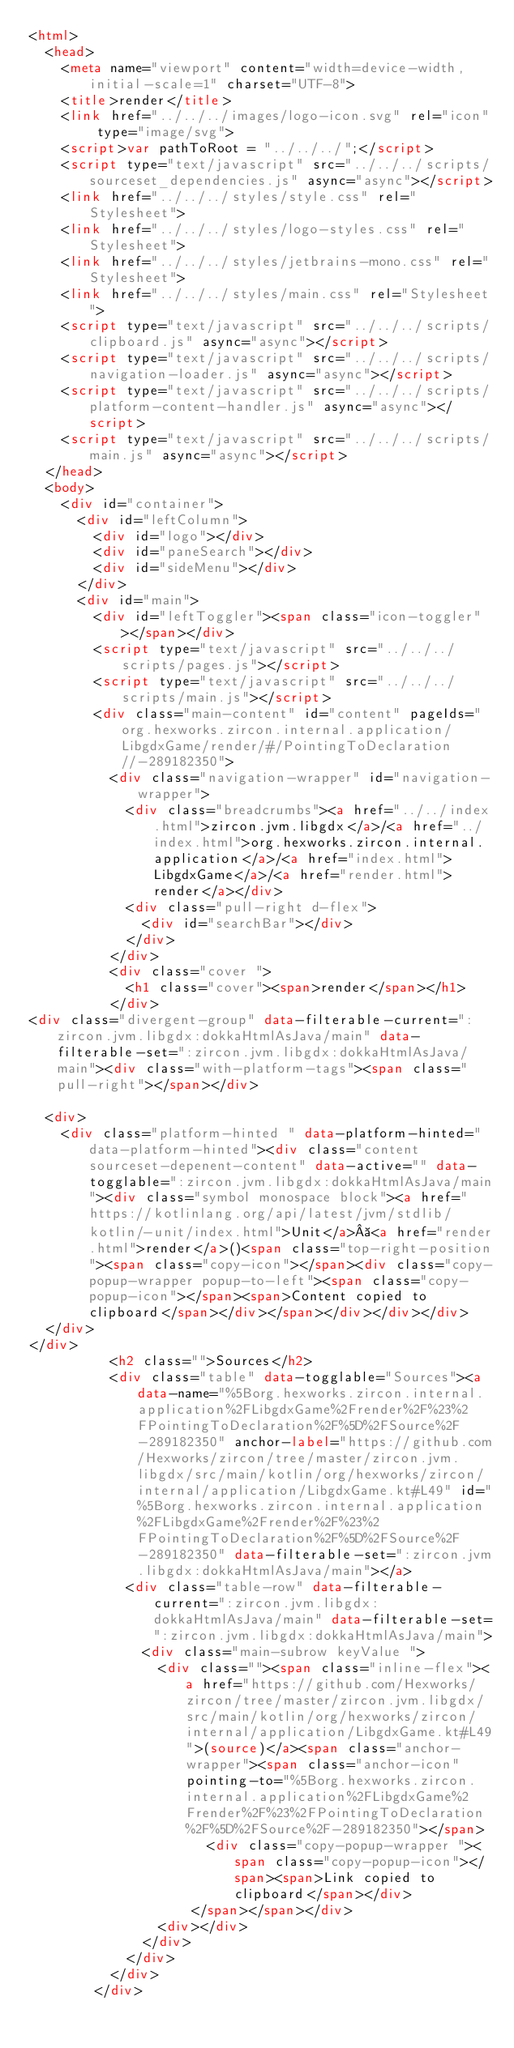Convert code to text. <code><loc_0><loc_0><loc_500><loc_500><_HTML_><html>
  <head>
    <meta name="viewport" content="width=device-width, initial-scale=1" charset="UTF-8">
    <title>render</title>
    <link href="../../../images/logo-icon.svg" rel="icon" type="image/svg">
    <script>var pathToRoot = "../../../";</script>
    <script type="text/javascript" src="../../../scripts/sourceset_dependencies.js" async="async"></script>
    <link href="../../../styles/style.css" rel="Stylesheet">
    <link href="../../../styles/logo-styles.css" rel="Stylesheet">
    <link href="../../../styles/jetbrains-mono.css" rel="Stylesheet">
    <link href="../../../styles/main.css" rel="Stylesheet">
    <script type="text/javascript" src="../../../scripts/clipboard.js" async="async"></script>
    <script type="text/javascript" src="../../../scripts/navigation-loader.js" async="async"></script>
    <script type="text/javascript" src="../../../scripts/platform-content-handler.js" async="async"></script>
    <script type="text/javascript" src="../../../scripts/main.js" async="async"></script>
  </head>
  <body>
    <div id="container">
      <div id="leftColumn">
        <div id="logo"></div>
        <div id="paneSearch"></div>
        <div id="sideMenu"></div>
      </div>
      <div id="main">
        <div id="leftToggler"><span class="icon-toggler"></span></div>
        <script type="text/javascript" src="../../../scripts/pages.js"></script>
        <script type="text/javascript" src="../../../scripts/main.js"></script>
        <div class="main-content" id="content" pageIds="org.hexworks.zircon.internal.application/LibgdxGame/render/#/PointingToDeclaration//-289182350">
          <div class="navigation-wrapper" id="navigation-wrapper">
            <div class="breadcrumbs"><a href="../../index.html">zircon.jvm.libgdx</a>/<a href="../index.html">org.hexworks.zircon.internal.application</a>/<a href="index.html">LibgdxGame</a>/<a href="render.html">render</a></div>
            <div class="pull-right d-flex">
              <div id="searchBar"></div>
            </div>
          </div>
          <div class="cover ">
            <h1 class="cover"><span>render</span></h1>
          </div>
<div class="divergent-group" data-filterable-current=":zircon.jvm.libgdx:dokkaHtmlAsJava/main" data-filterable-set=":zircon.jvm.libgdx:dokkaHtmlAsJava/main"><div class="with-platform-tags"><span class="pull-right"></span></div>

  <div>
    <div class="platform-hinted " data-platform-hinted="data-platform-hinted"><div class="content sourceset-depenent-content" data-active="" data-togglable=":zircon.jvm.libgdx:dokkaHtmlAsJava/main"><div class="symbol monospace block"><a href="https://kotlinlang.org/api/latest/jvm/stdlib/kotlin/-unit/index.html">Unit</a> <a href="render.html">render</a>()<span class="top-right-position"><span class="copy-icon"></span><div class="copy-popup-wrapper popup-to-left"><span class="copy-popup-icon"></span><span>Content copied to clipboard</span></div></span></div></div></div>
  </div>
</div>
          <h2 class="">Sources</h2>
          <div class="table" data-togglable="Sources"><a data-name="%5Borg.hexworks.zircon.internal.application%2FLibgdxGame%2Frender%2F%23%2FPointingToDeclaration%2F%5D%2FSource%2F-289182350" anchor-label="https://github.com/Hexworks/zircon/tree/master/zircon.jvm.libgdx/src/main/kotlin/org/hexworks/zircon/internal/application/LibgdxGame.kt#L49" id="%5Borg.hexworks.zircon.internal.application%2FLibgdxGame%2Frender%2F%23%2FPointingToDeclaration%2F%5D%2FSource%2F-289182350" data-filterable-set=":zircon.jvm.libgdx:dokkaHtmlAsJava/main"></a>
            <div class="table-row" data-filterable-current=":zircon.jvm.libgdx:dokkaHtmlAsJava/main" data-filterable-set=":zircon.jvm.libgdx:dokkaHtmlAsJava/main">
              <div class="main-subrow keyValue ">
                <div class=""><span class="inline-flex"><a href="https://github.com/Hexworks/zircon/tree/master/zircon.jvm.libgdx/src/main/kotlin/org/hexworks/zircon/internal/application/LibgdxGame.kt#L49">(source)</a><span class="anchor-wrapper"><span class="anchor-icon" pointing-to="%5Borg.hexworks.zircon.internal.application%2FLibgdxGame%2Frender%2F%23%2FPointingToDeclaration%2F%5D%2FSource%2F-289182350"></span>
                      <div class="copy-popup-wrapper "><span class="copy-popup-icon"></span><span>Link copied to clipboard</span></div>
                    </span></span></div>
                <div></div>
              </div>
            </div>
          </div>
        </div></code> 